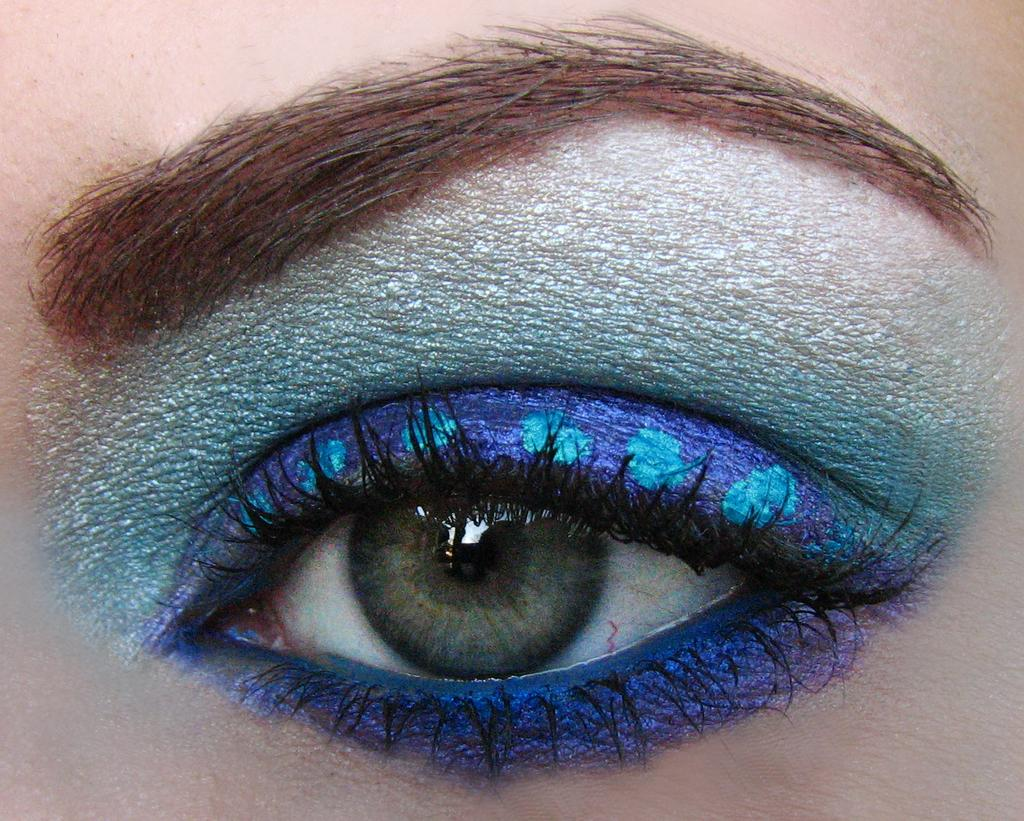What is the main subject of the image? The main subject of the image is an eye. How is the eye depicted in the image? The eye is beautifully shaded with blue color around it. What type of cloth is draped over the eye in the image? There is no cloth present in the image; it only features an eye with blue color shading around it. What act is being performed by the eye in the image? The eye is not performing any act in the image; it is simply depicted as it is. 